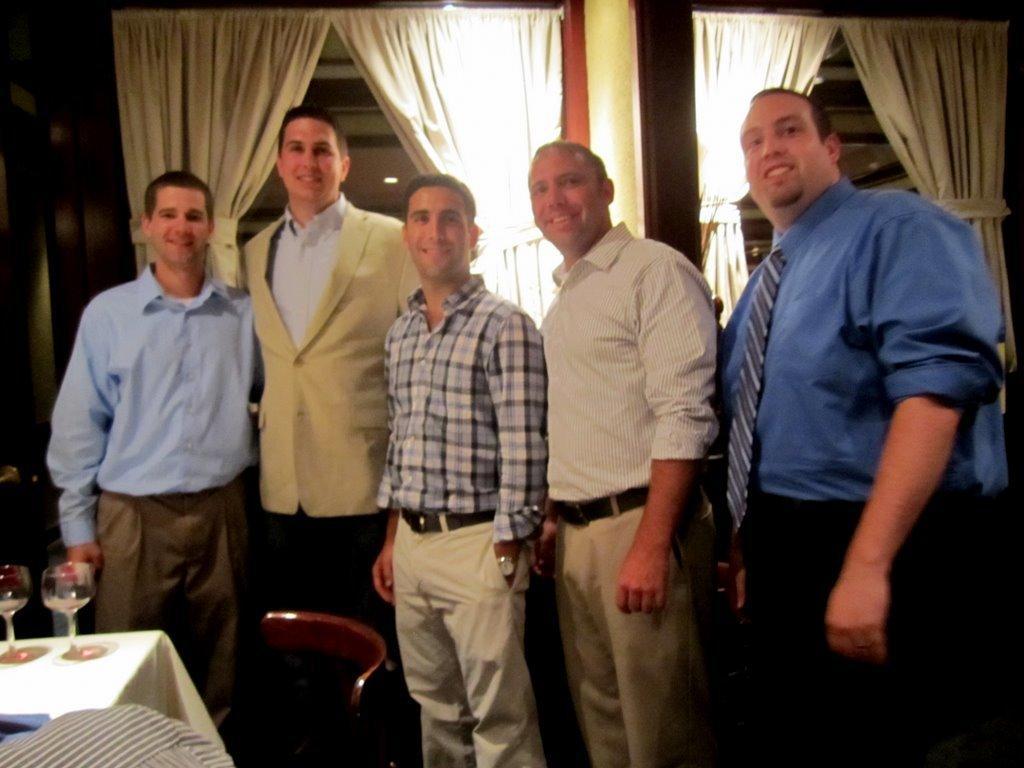Please provide a concise description of this image. In this picture we can see five people they are all standing and they are all laughing, in front of them we can find glasses on the table, and we can see some curtains. 